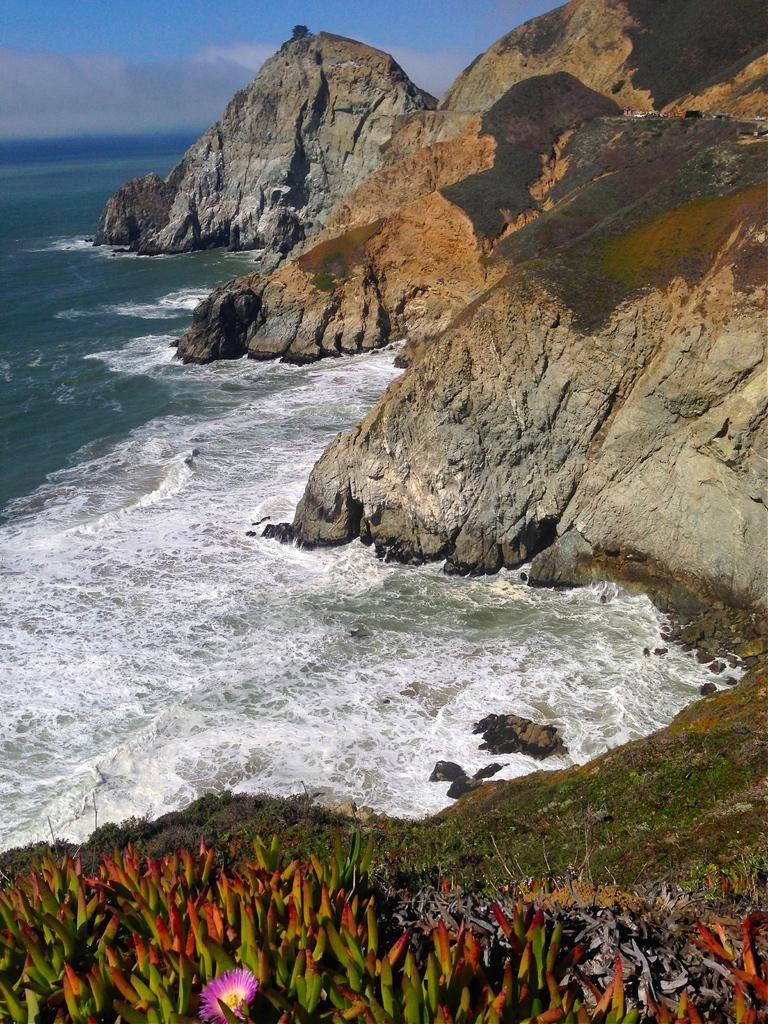What type of geological formation is on the right side of the image? There are rock hills on the right side of the image. What natural element is present in the image? There is water in the image. What type of vegetation can be seen at the bottom of the image? There are plants with flowers at the bottom of the image. How does the metal transport the swimmers in the image? There is no metal or swimmers present in the image. What type of creature is shown interacting with the plants with flowers in the image? There is no creature shown interacting with the plants with flowers in the image; only the plants and flowers are present. 